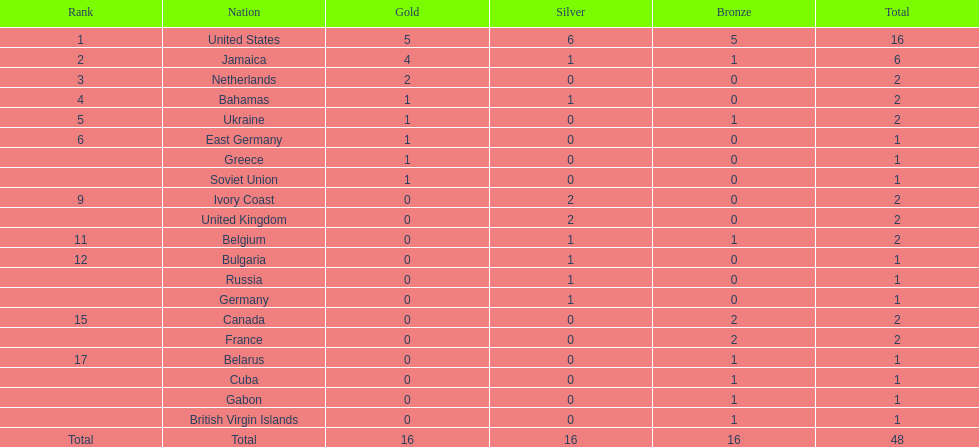What is the total number of gold medals won by both the us and jamaica? 9. 